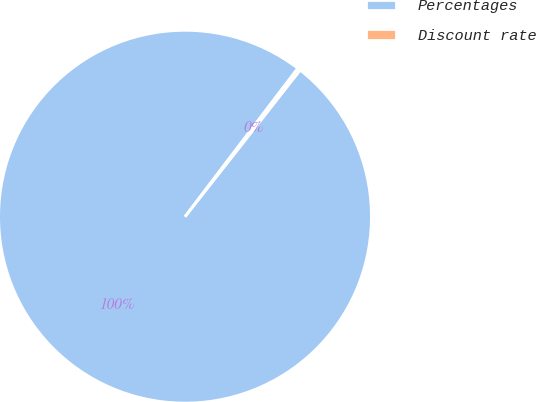Convert chart. <chart><loc_0><loc_0><loc_500><loc_500><pie_chart><fcel>Percentages<fcel>Discount rate<nl><fcel>99.75%<fcel>0.25%<nl></chart> 